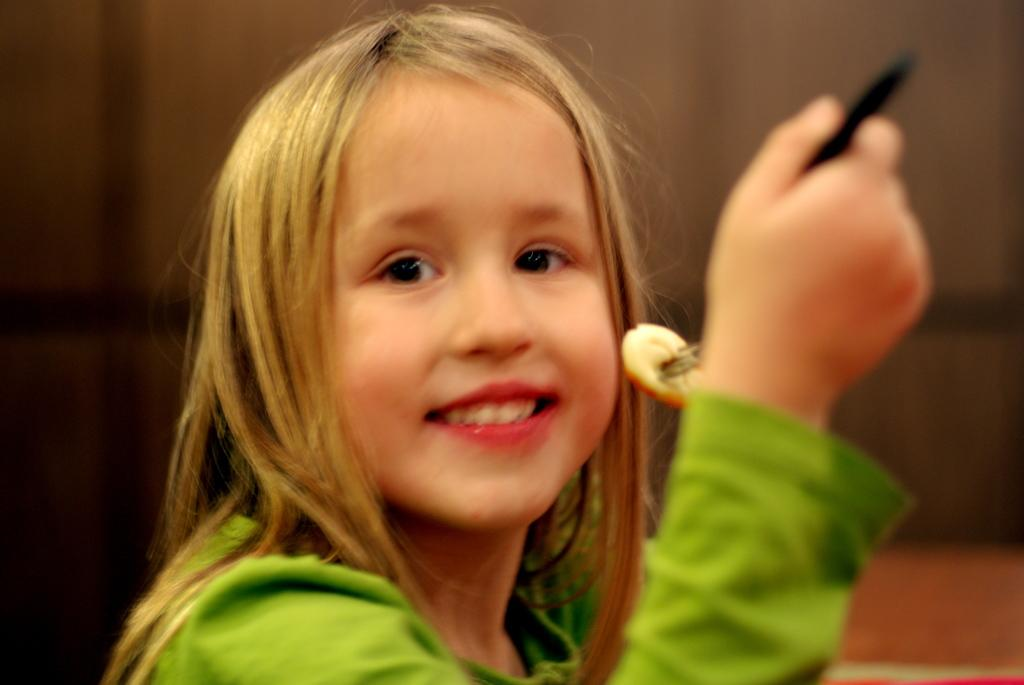Who is the main subject in the image? There is a girl in the image. What is the girl doing in the image? The girl is holding food with a fork. What is the girl wearing in the image? The girl is wearing a green t-shirt. What is the girl's facial expression in the image? The girl is smiling. What story is the girl telling in the image? There is no indication in the image that the girl is telling a story. 